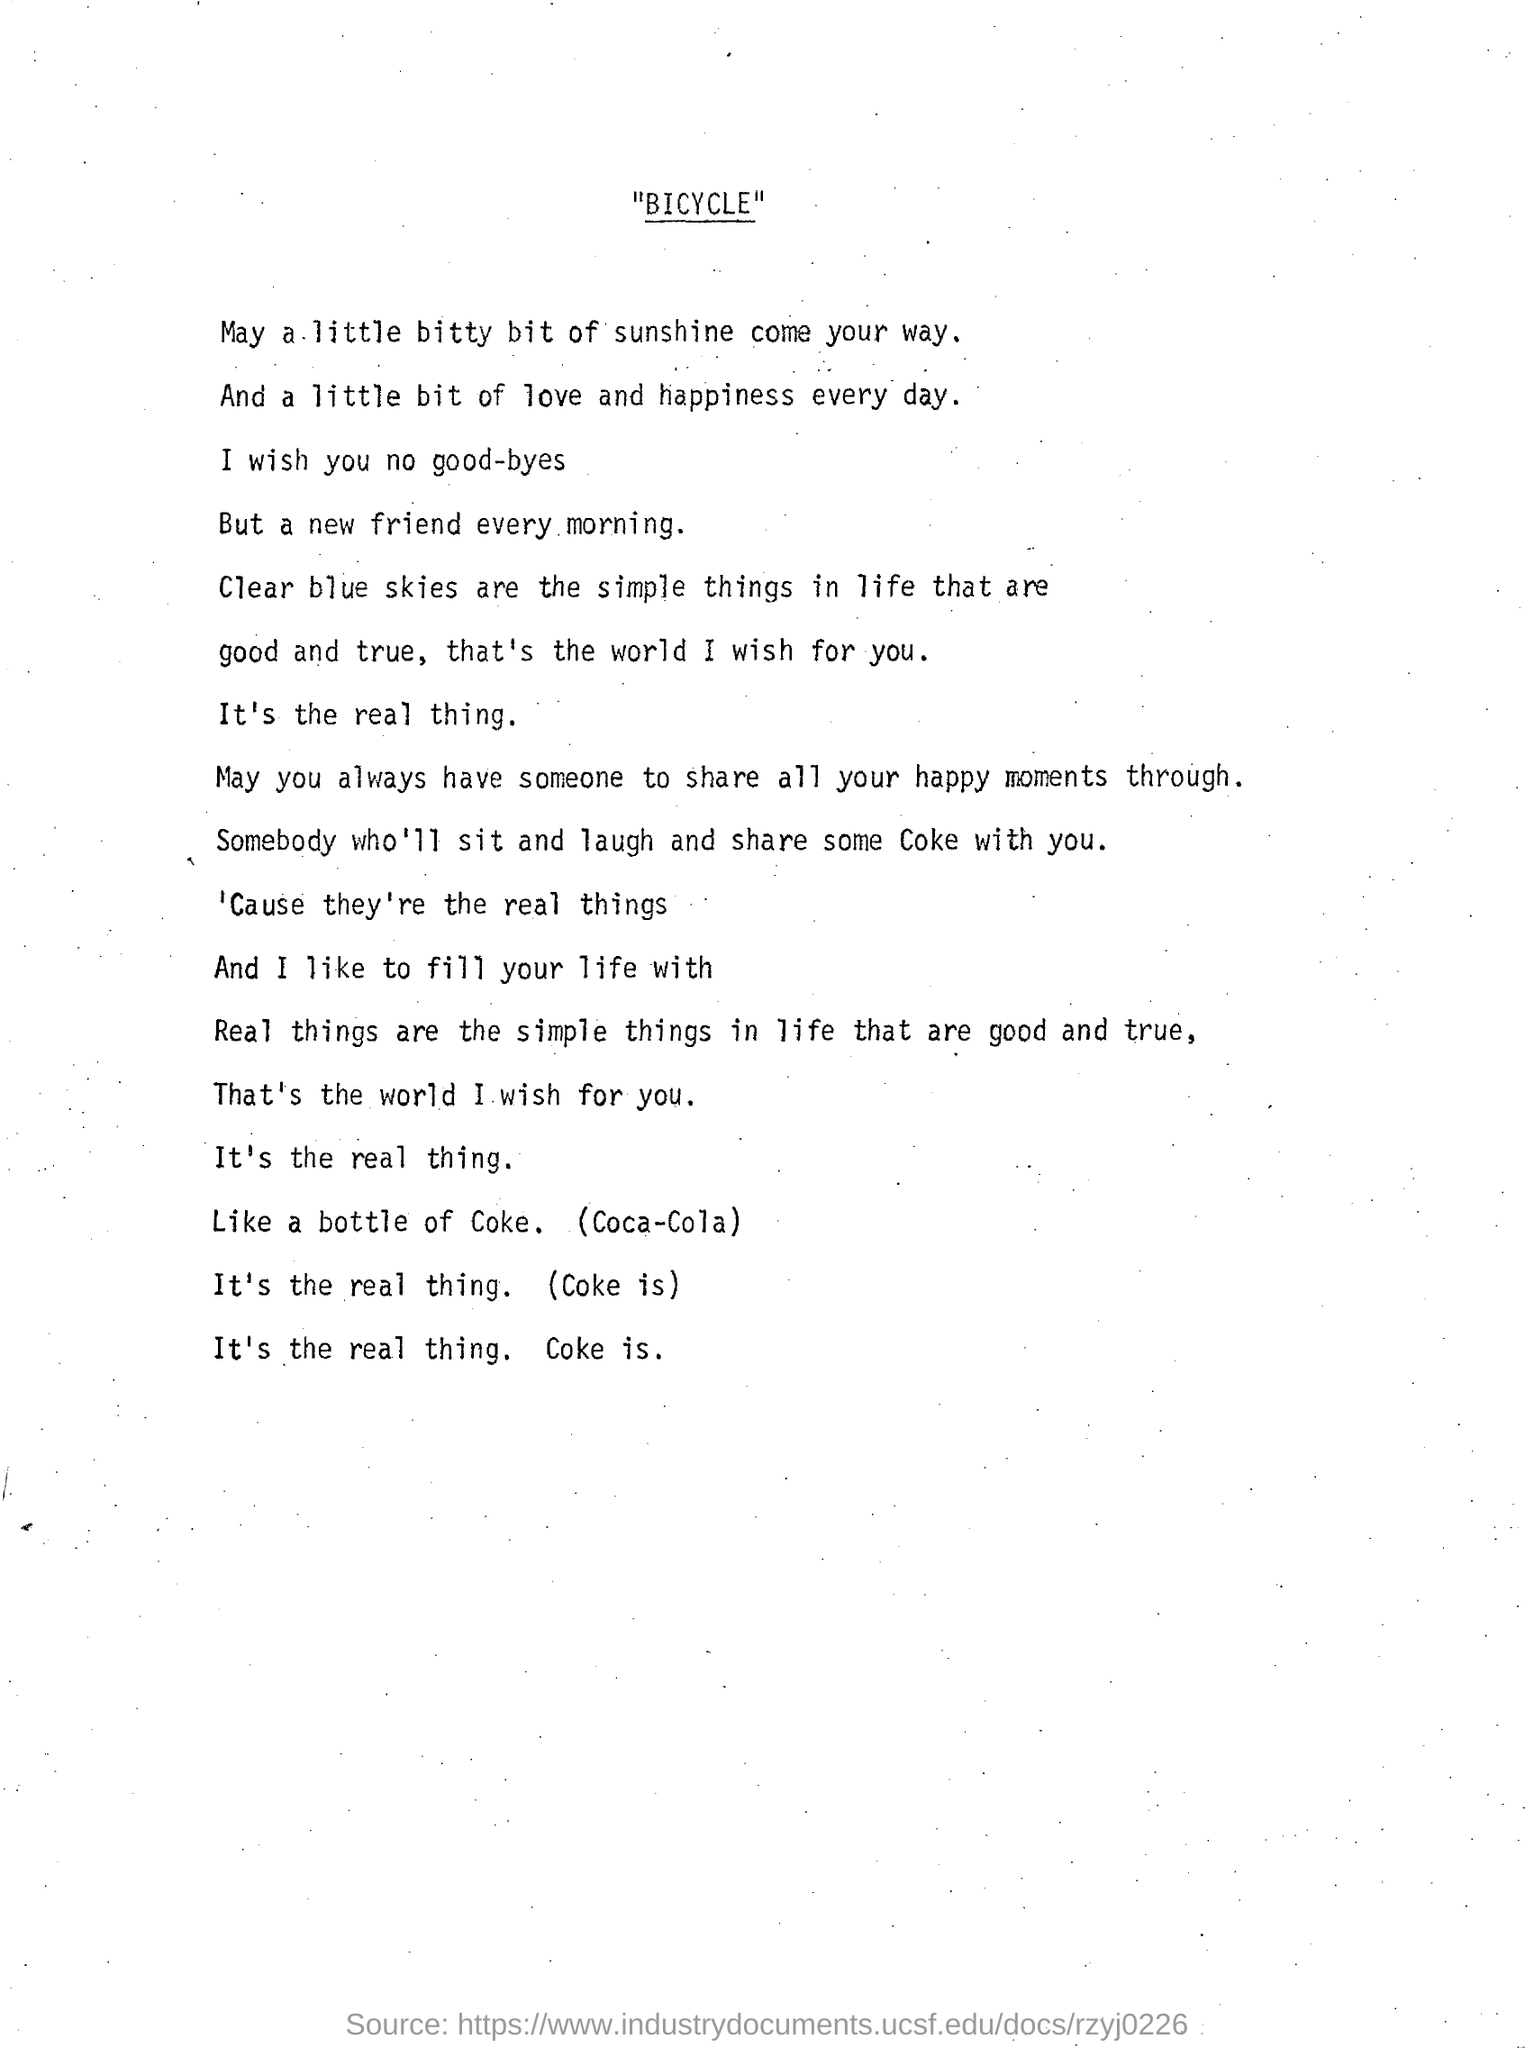What is the title of this document?
Your answer should be compact. "BICYCLE". 